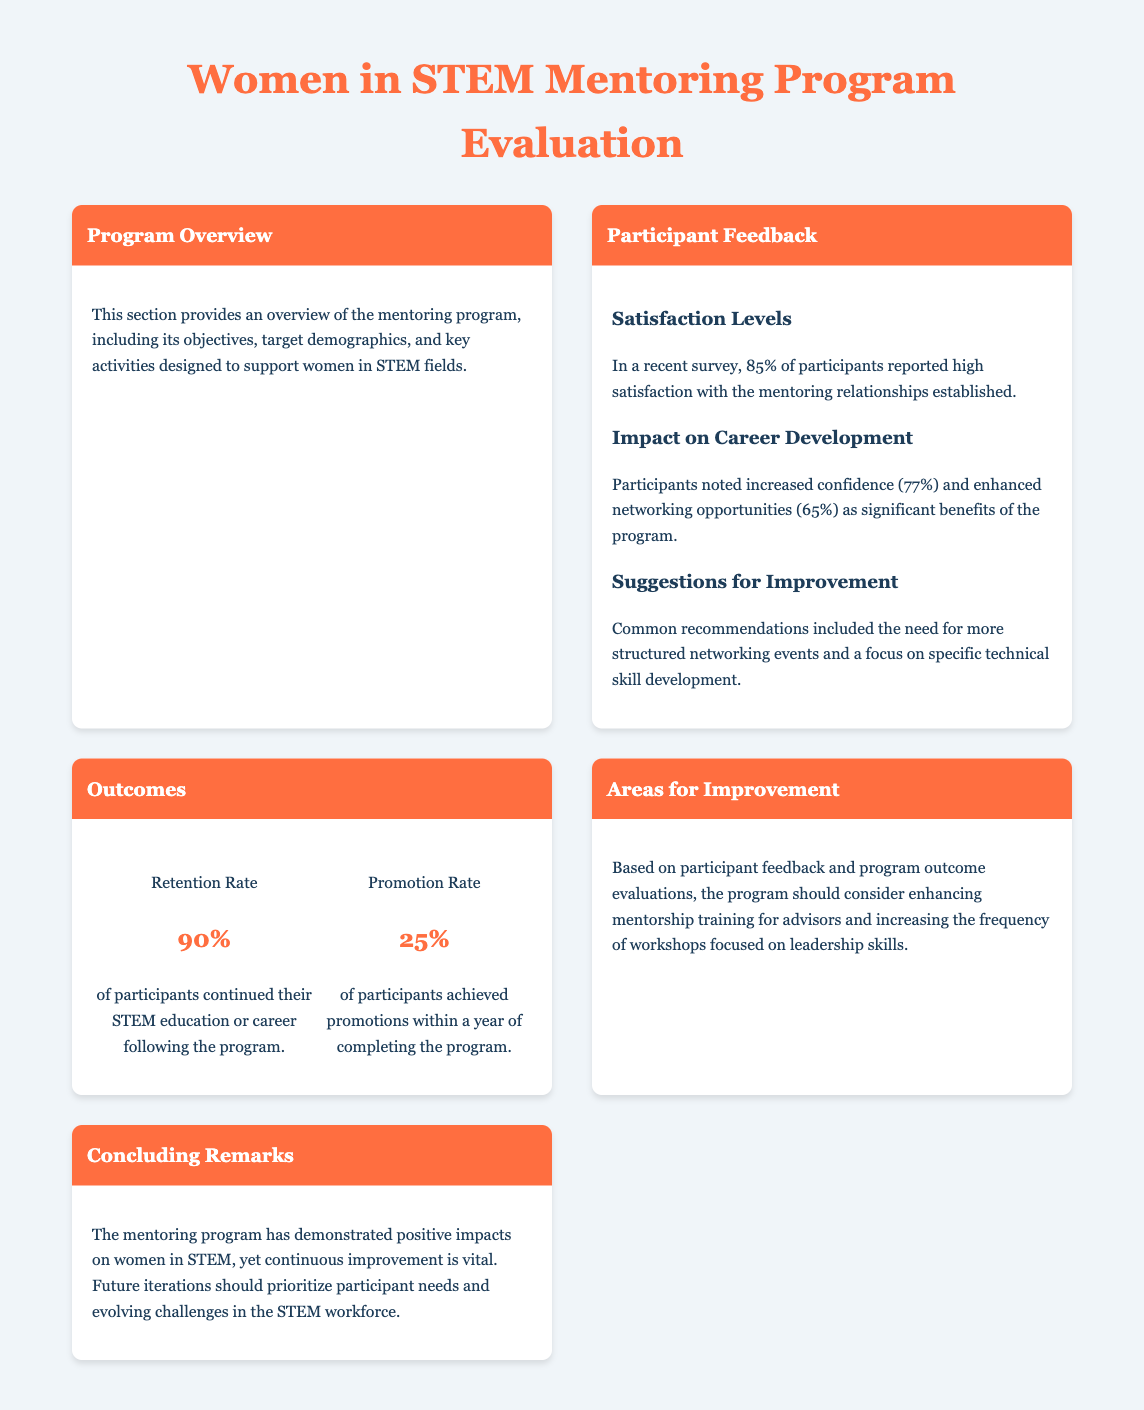What percentage of participants reported high satisfaction with the mentoring relationships? The satisfaction level is indicated in the Participant Feedback section, where 85% of participants reported high satisfaction.
Answer: 85% What is the retention rate of participants in the program? The Outcomes section presents statistics, showing that 90% of participants continued their STEM education or career.
Answer: 90% What significant benefit was noted by 77% of participants? The Participant Feedback section highlights increased confidence as a significant benefit reported by 77% of participants.
Answer: Increased confidence What suggestion was commonly made for program improvement? The Participant Feedback section mentions that a common recommendation included the need for more structured networking events.
Answer: More structured networking events What percent of participants achieved promotions within a year? The Outcomes section states that 25% of participants achieved promotions within a year of completing the program.
Answer: 25% What is a recommended focus for future workshops? The Areas for Improvement section suggests increasing the frequency of workshops focused on leadership skills.
Answer: Leadership skills What percentage of participants noted enhanced networking opportunities as a benefit? The Participant Feedback indicates that 65% of participants noted enhanced networking opportunities.
Answer: 65% What is the overall conclusion about the mentoring program? The Concluding Remarks state that the mentoring program has demonstrated positive impacts but emphasizes the need for continuous improvement.
Answer: Positive impacts and continuous improvement 